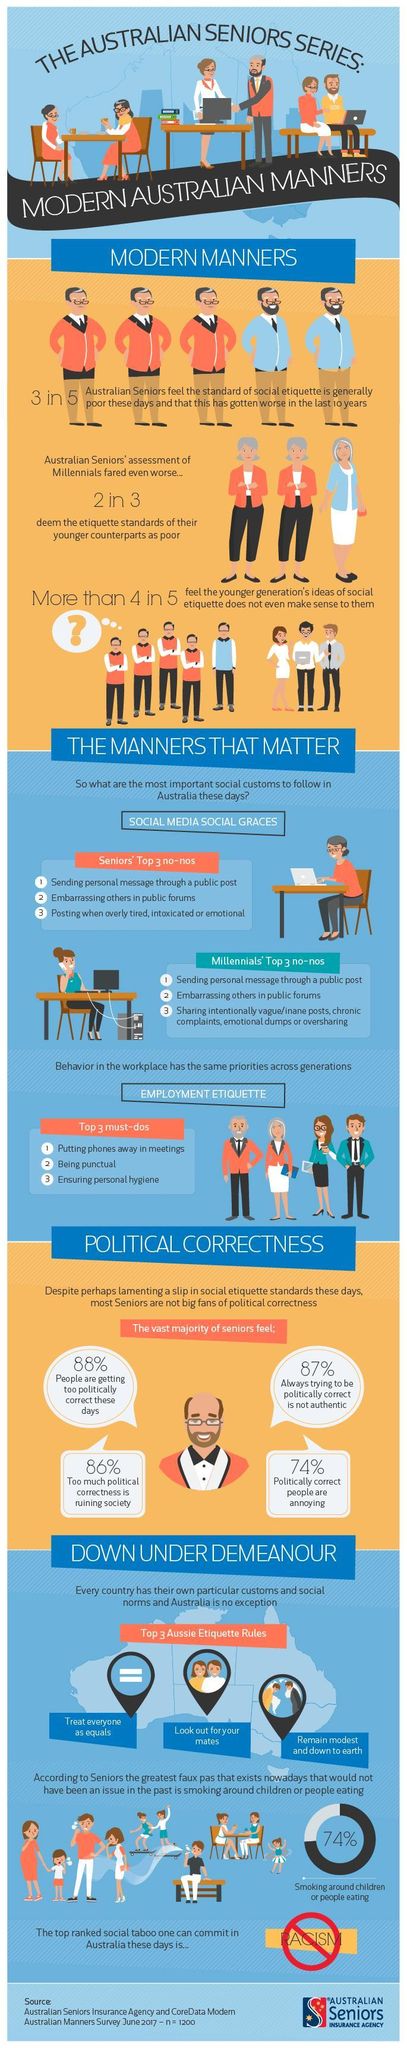What percentage of Australian seniors feel that politically correct people are annoying?
Answer the question with a short phrase. 74% What percentage of Australian seniors feel that too much political correctness is ruining society? 86% 